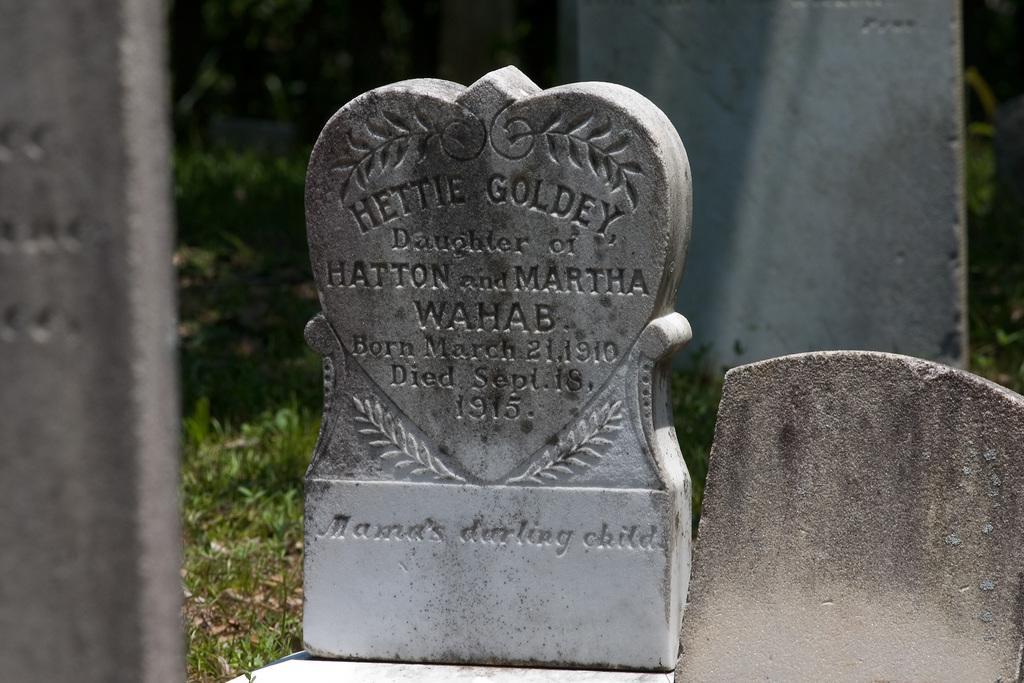Can you describe this image briefly? In this picture we can see a tombstone with letters engraved on it. 